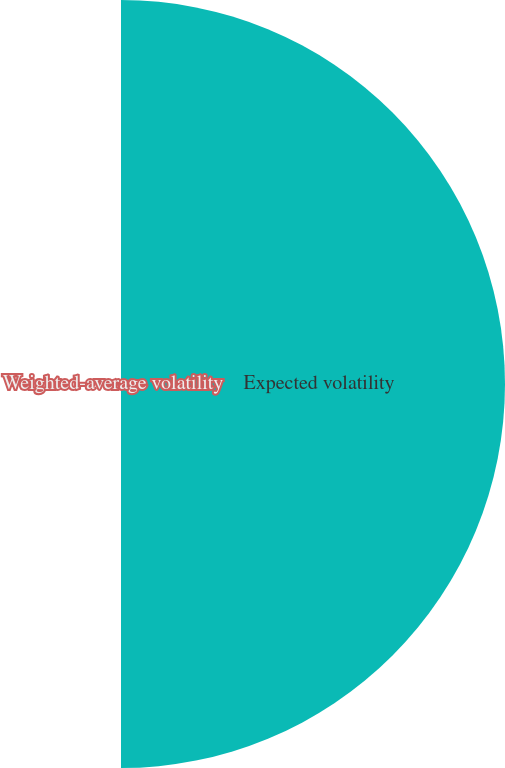<chart> <loc_0><loc_0><loc_500><loc_500><pie_chart><fcel>Expected volatility<fcel>Weighted-average volatility<nl><fcel>98.97%<fcel>1.03%<nl></chart> 